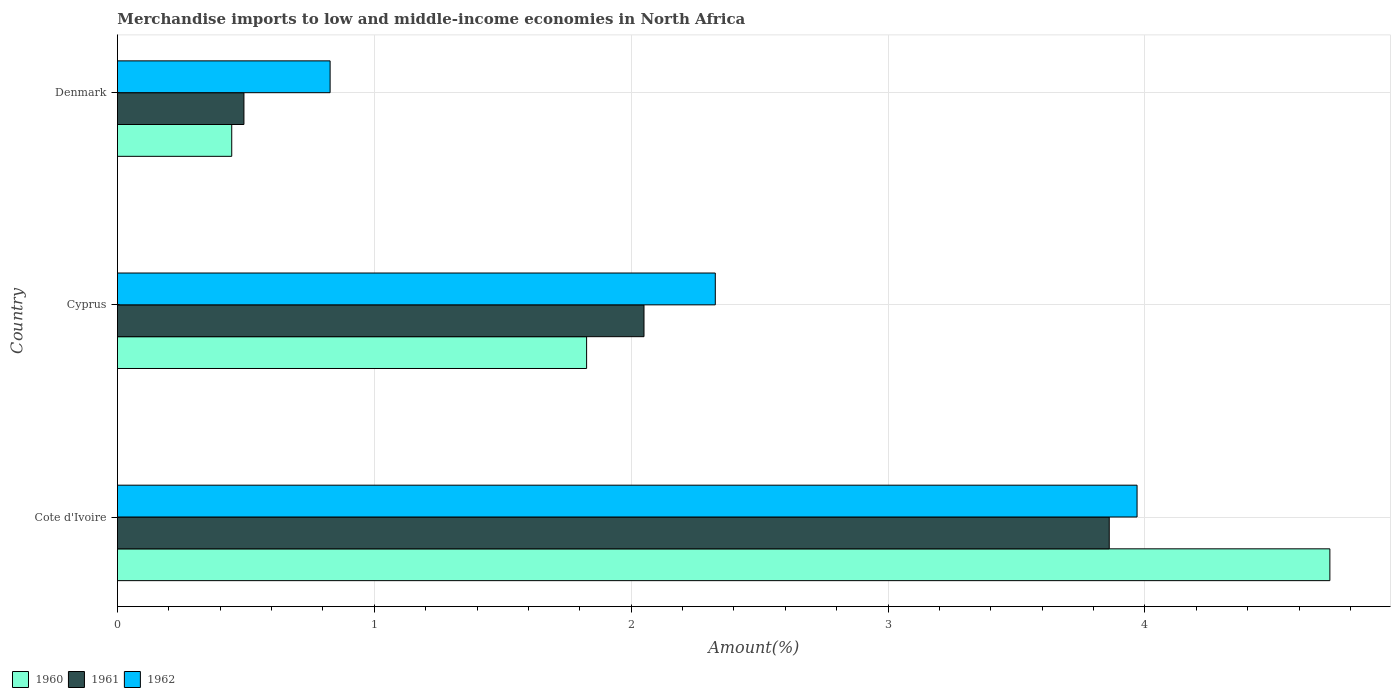How many different coloured bars are there?
Keep it short and to the point. 3. How many groups of bars are there?
Make the answer very short. 3. Are the number of bars per tick equal to the number of legend labels?
Make the answer very short. Yes. How many bars are there on the 3rd tick from the top?
Provide a short and direct response. 3. What is the label of the 3rd group of bars from the top?
Provide a succinct answer. Cote d'Ivoire. In how many cases, is the number of bars for a given country not equal to the number of legend labels?
Give a very brief answer. 0. What is the percentage of amount earned from merchandise imports in 1961 in Cyprus?
Your answer should be compact. 2.05. Across all countries, what is the maximum percentage of amount earned from merchandise imports in 1961?
Offer a very short reply. 3.86. Across all countries, what is the minimum percentage of amount earned from merchandise imports in 1960?
Your response must be concise. 0.45. In which country was the percentage of amount earned from merchandise imports in 1962 maximum?
Ensure brevity in your answer.  Cote d'Ivoire. What is the total percentage of amount earned from merchandise imports in 1961 in the graph?
Give a very brief answer. 6.4. What is the difference between the percentage of amount earned from merchandise imports in 1962 in Cote d'Ivoire and that in Denmark?
Offer a terse response. 3.14. What is the difference between the percentage of amount earned from merchandise imports in 1962 in Denmark and the percentage of amount earned from merchandise imports in 1960 in Cote d'Ivoire?
Your response must be concise. -3.89. What is the average percentage of amount earned from merchandise imports in 1962 per country?
Your answer should be very brief. 2.37. What is the difference between the percentage of amount earned from merchandise imports in 1961 and percentage of amount earned from merchandise imports in 1960 in Denmark?
Ensure brevity in your answer.  0.05. What is the ratio of the percentage of amount earned from merchandise imports in 1961 in Cote d'Ivoire to that in Cyprus?
Ensure brevity in your answer.  1.88. Is the difference between the percentage of amount earned from merchandise imports in 1961 in Cote d'Ivoire and Denmark greater than the difference between the percentage of amount earned from merchandise imports in 1960 in Cote d'Ivoire and Denmark?
Provide a short and direct response. No. What is the difference between the highest and the second highest percentage of amount earned from merchandise imports in 1960?
Ensure brevity in your answer.  2.89. What is the difference between the highest and the lowest percentage of amount earned from merchandise imports in 1962?
Your response must be concise. 3.14. Is the sum of the percentage of amount earned from merchandise imports in 1960 in Cote d'Ivoire and Cyprus greater than the maximum percentage of amount earned from merchandise imports in 1962 across all countries?
Your answer should be very brief. Yes. How many bars are there?
Give a very brief answer. 9. What is the title of the graph?
Ensure brevity in your answer.  Merchandise imports to low and middle-income economies in North Africa. Does "1994" appear as one of the legend labels in the graph?
Keep it short and to the point. No. What is the label or title of the X-axis?
Keep it short and to the point. Amount(%). What is the label or title of the Y-axis?
Your answer should be compact. Country. What is the Amount(%) of 1960 in Cote d'Ivoire?
Ensure brevity in your answer.  4.72. What is the Amount(%) of 1961 in Cote d'Ivoire?
Keep it short and to the point. 3.86. What is the Amount(%) of 1962 in Cote d'Ivoire?
Keep it short and to the point. 3.97. What is the Amount(%) of 1960 in Cyprus?
Offer a very short reply. 1.83. What is the Amount(%) of 1961 in Cyprus?
Provide a succinct answer. 2.05. What is the Amount(%) in 1962 in Cyprus?
Offer a terse response. 2.33. What is the Amount(%) in 1960 in Denmark?
Offer a terse response. 0.45. What is the Amount(%) of 1961 in Denmark?
Your response must be concise. 0.49. What is the Amount(%) in 1962 in Denmark?
Keep it short and to the point. 0.83. Across all countries, what is the maximum Amount(%) in 1960?
Ensure brevity in your answer.  4.72. Across all countries, what is the maximum Amount(%) in 1961?
Keep it short and to the point. 3.86. Across all countries, what is the maximum Amount(%) in 1962?
Ensure brevity in your answer.  3.97. Across all countries, what is the minimum Amount(%) of 1960?
Keep it short and to the point. 0.45. Across all countries, what is the minimum Amount(%) of 1961?
Offer a terse response. 0.49. Across all countries, what is the minimum Amount(%) of 1962?
Offer a very short reply. 0.83. What is the total Amount(%) of 1960 in the graph?
Ensure brevity in your answer.  6.99. What is the total Amount(%) in 1961 in the graph?
Offer a very short reply. 6.4. What is the total Amount(%) in 1962 in the graph?
Offer a very short reply. 7.12. What is the difference between the Amount(%) in 1960 in Cote d'Ivoire and that in Cyprus?
Provide a short and direct response. 2.89. What is the difference between the Amount(%) in 1961 in Cote d'Ivoire and that in Cyprus?
Offer a very short reply. 1.81. What is the difference between the Amount(%) of 1962 in Cote d'Ivoire and that in Cyprus?
Make the answer very short. 1.64. What is the difference between the Amount(%) of 1960 in Cote d'Ivoire and that in Denmark?
Your answer should be compact. 4.27. What is the difference between the Amount(%) in 1961 in Cote d'Ivoire and that in Denmark?
Your response must be concise. 3.37. What is the difference between the Amount(%) of 1962 in Cote d'Ivoire and that in Denmark?
Ensure brevity in your answer.  3.14. What is the difference between the Amount(%) in 1960 in Cyprus and that in Denmark?
Provide a short and direct response. 1.38. What is the difference between the Amount(%) in 1961 in Cyprus and that in Denmark?
Provide a succinct answer. 1.56. What is the difference between the Amount(%) in 1962 in Cyprus and that in Denmark?
Your answer should be compact. 1.5. What is the difference between the Amount(%) of 1960 in Cote d'Ivoire and the Amount(%) of 1961 in Cyprus?
Keep it short and to the point. 2.67. What is the difference between the Amount(%) in 1960 in Cote d'Ivoire and the Amount(%) in 1962 in Cyprus?
Offer a terse response. 2.39. What is the difference between the Amount(%) of 1961 in Cote d'Ivoire and the Amount(%) of 1962 in Cyprus?
Offer a very short reply. 1.53. What is the difference between the Amount(%) in 1960 in Cote d'Ivoire and the Amount(%) in 1961 in Denmark?
Offer a terse response. 4.23. What is the difference between the Amount(%) in 1960 in Cote d'Ivoire and the Amount(%) in 1962 in Denmark?
Your response must be concise. 3.89. What is the difference between the Amount(%) in 1961 in Cote d'Ivoire and the Amount(%) in 1962 in Denmark?
Your answer should be very brief. 3.03. What is the difference between the Amount(%) in 1960 in Cyprus and the Amount(%) in 1961 in Denmark?
Offer a terse response. 1.33. What is the difference between the Amount(%) of 1960 in Cyprus and the Amount(%) of 1962 in Denmark?
Your response must be concise. 1. What is the difference between the Amount(%) in 1961 in Cyprus and the Amount(%) in 1962 in Denmark?
Your response must be concise. 1.22. What is the average Amount(%) in 1960 per country?
Your response must be concise. 2.33. What is the average Amount(%) of 1961 per country?
Provide a succinct answer. 2.13. What is the average Amount(%) in 1962 per country?
Your response must be concise. 2.37. What is the difference between the Amount(%) in 1960 and Amount(%) in 1961 in Cote d'Ivoire?
Your response must be concise. 0.86. What is the difference between the Amount(%) in 1960 and Amount(%) in 1962 in Cote d'Ivoire?
Offer a very short reply. 0.75. What is the difference between the Amount(%) of 1961 and Amount(%) of 1962 in Cote d'Ivoire?
Provide a short and direct response. -0.11. What is the difference between the Amount(%) in 1960 and Amount(%) in 1961 in Cyprus?
Your answer should be compact. -0.22. What is the difference between the Amount(%) of 1960 and Amount(%) of 1962 in Cyprus?
Your answer should be very brief. -0.5. What is the difference between the Amount(%) in 1961 and Amount(%) in 1962 in Cyprus?
Ensure brevity in your answer.  -0.28. What is the difference between the Amount(%) in 1960 and Amount(%) in 1961 in Denmark?
Provide a succinct answer. -0.05. What is the difference between the Amount(%) in 1960 and Amount(%) in 1962 in Denmark?
Provide a succinct answer. -0.38. What is the difference between the Amount(%) in 1961 and Amount(%) in 1962 in Denmark?
Provide a succinct answer. -0.34. What is the ratio of the Amount(%) of 1960 in Cote d'Ivoire to that in Cyprus?
Your response must be concise. 2.58. What is the ratio of the Amount(%) in 1961 in Cote d'Ivoire to that in Cyprus?
Ensure brevity in your answer.  1.88. What is the ratio of the Amount(%) in 1962 in Cote d'Ivoire to that in Cyprus?
Offer a very short reply. 1.71. What is the ratio of the Amount(%) of 1960 in Cote d'Ivoire to that in Denmark?
Your response must be concise. 10.61. What is the ratio of the Amount(%) of 1961 in Cote d'Ivoire to that in Denmark?
Ensure brevity in your answer.  7.84. What is the ratio of the Amount(%) of 1962 in Cote d'Ivoire to that in Denmark?
Ensure brevity in your answer.  4.79. What is the ratio of the Amount(%) of 1960 in Cyprus to that in Denmark?
Your answer should be compact. 4.1. What is the ratio of the Amount(%) in 1961 in Cyprus to that in Denmark?
Make the answer very short. 4.16. What is the ratio of the Amount(%) in 1962 in Cyprus to that in Denmark?
Keep it short and to the point. 2.81. What is the difference between the highest and the second highest Amount(%) of 1960?
Your response must be concise. 2.89. What is the difference between the highest and the second highest Amount(%) in 1961?
Keep it short and to the point. 1.81. What is the difference between the highest and the second highest Amount(%) in 1962?
Provide a short and direct response. 1.64. What is the difference between the highest and the lowest Amount(%) in 1960?
Offer a terse response. 4.27. What is the difference between the highest and the lowest Amount(%) of 1961?
Your answer should be very brief. 3.37. What is the difference between the highest and the lowest Amount(%) in 1962?
Give a very brief answer. 3.14. 